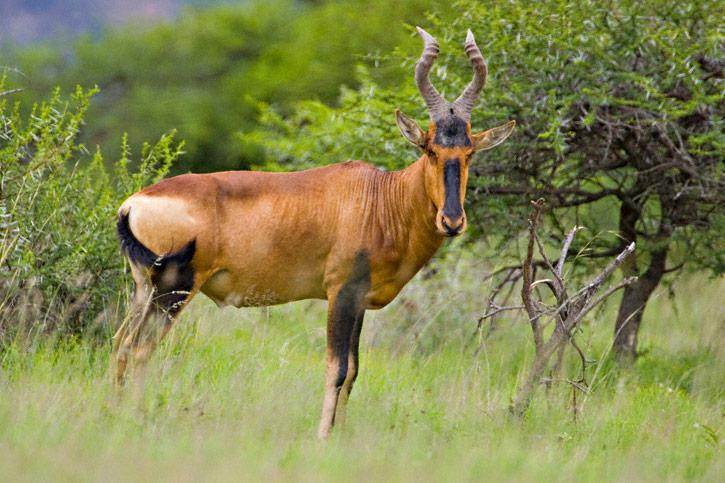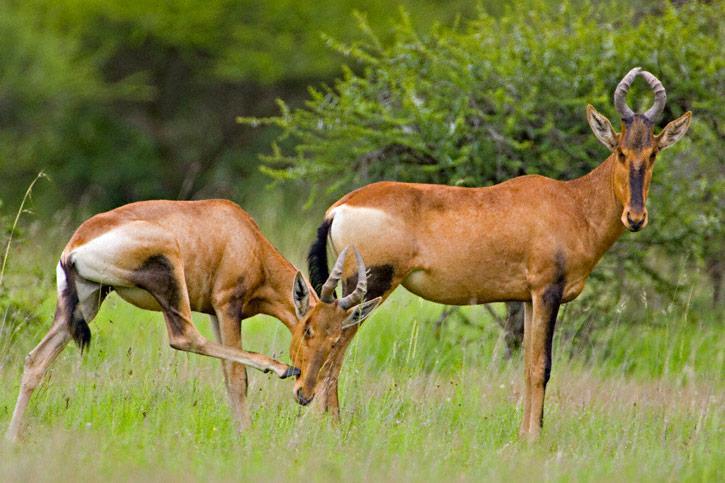The first image is the image on the left, the second image is the image on the right. Analyze the images presented: Is the assertion "There are 3 animals." valid? Answer yes or no. Yes. 